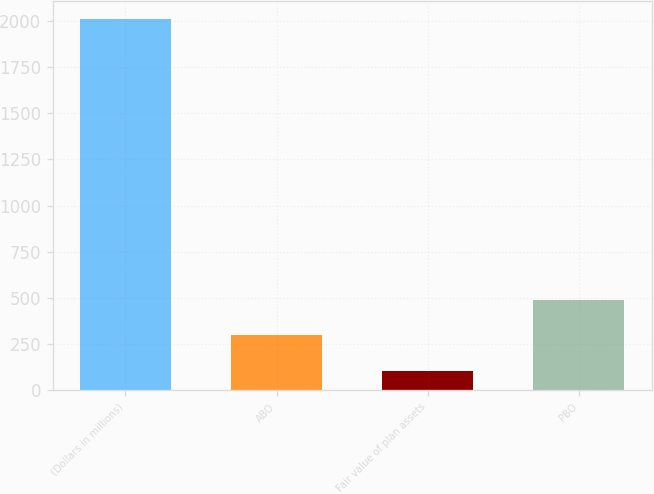Convert chart. <chart><loc_0><loc_0><loc_500><loc_500><bar_chart><fcel>(Dollars in millions)<fcel>ABO<fcel>Fair value of plan assets<fcel>PBO<nl><fcel>2010<fcel>296.4<fcel>106<fcel>486.8<nl></chart> 